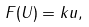<formula> <loc_0><loc_0><loc_500><loc_500>F ( U ) = k u ,</formula> 